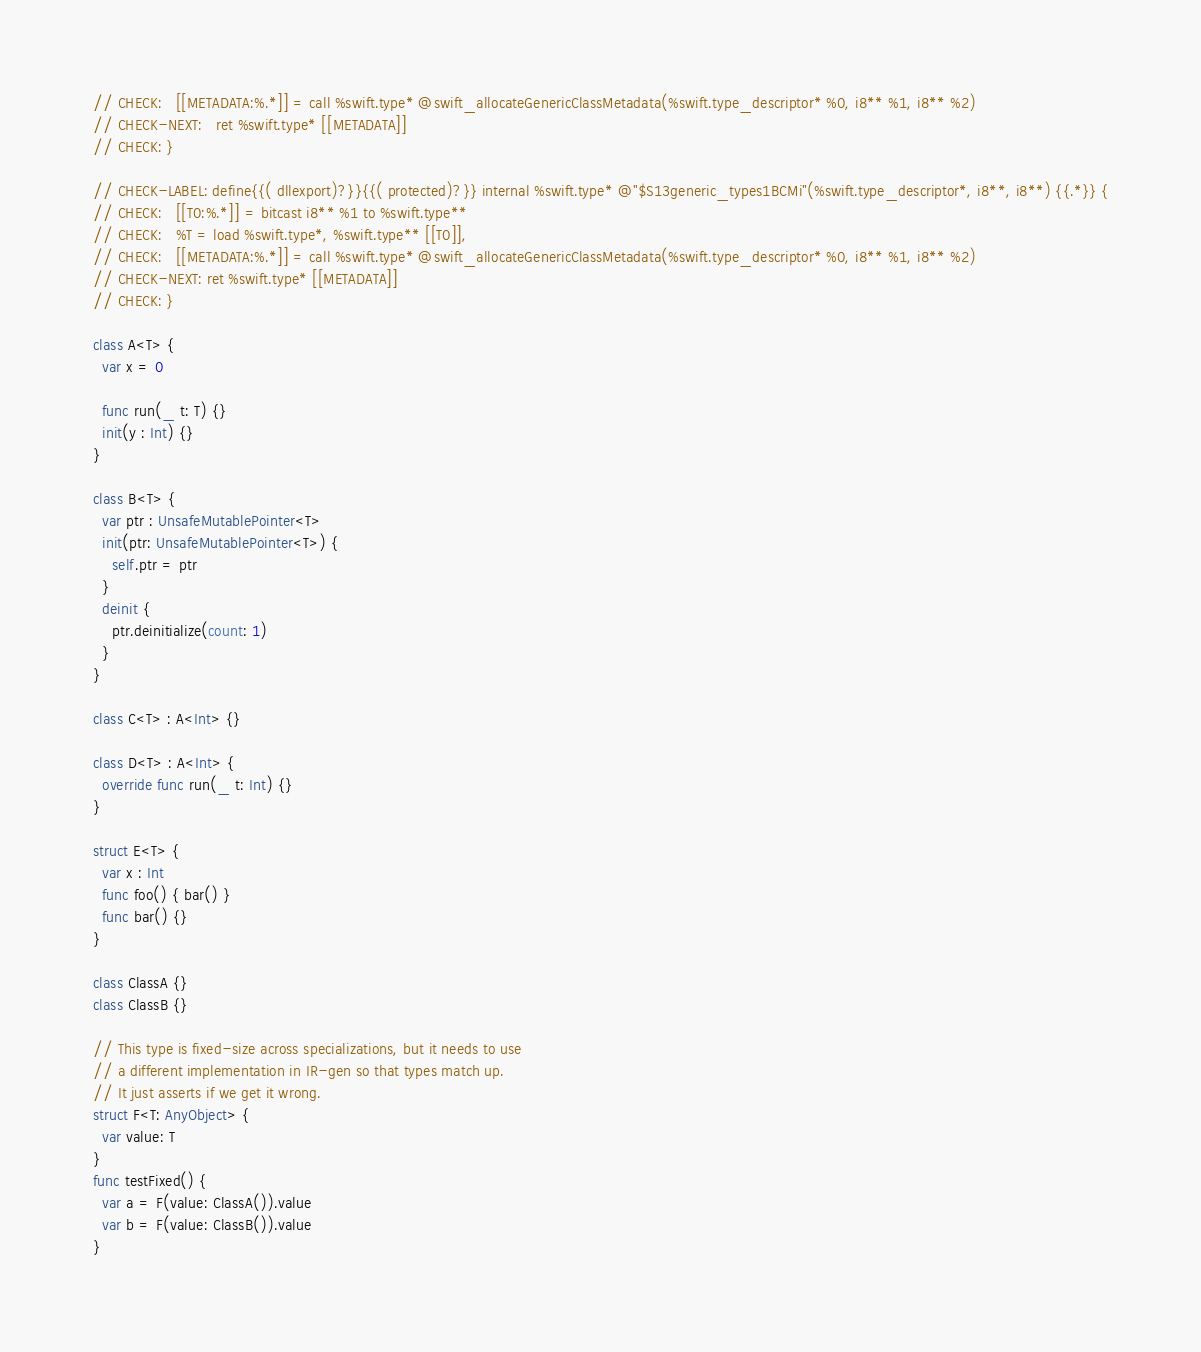Convert code to text. <code><loc_0><loc_0><loc_500><loc_500><_Swift_>// CHECK:   [[METADATA:%.*]] = call %swift.type* @swift_allocateGenericClassMetadata(%swift.type_descriptor* %0, i8** %1, i8** %2)
// CHECK-NEXT:   ret %swift.type* [[METADATA]]
// CHECK: }

// CHECK-LABEL: define{{( dllexport)?}}{{( protected)?}} internal %swift.type* @"$S13generic_types1BCMi"(%swift.type_descriptor*, i8**, i8**) {{.*}} {
// CHECK:   [[T0:%.*]] = bitcast i8** %1 to %swift.type**
// CHECK:   %T = load %swift.type*, %swift.type** [[T0]],
// CHECK:   [[METADATA:%.*]] = call %swift.type* @swift_allocateGenericClassMetadata(%swift.type_descriptor* %0, i8** %1, i8** %2)
// CHECK-NEXT: ret %swift.type* [[METADATA]]
// CHECK: }

class A<T> {
  var x = 0

  func run(_ t: T) {}
  init(y : Int) {}
}

class B<T> {
  var ptr : UnsafeMutablePointer<T>
  init(ptr: UnsafeMutablePointer<T>) {
    self.ptr = ptr
  }
  deinit {
    ptr.deinitialize(count: 1)
  }
}

class C<T> : A<Int> {}

class D<T> : A<Int> {
  override func run(_ t: Int) {}
}

struct E<T> {
  var x : Int
  func foo() { bar() }
  func bar() {}
}

class ClassA {}
class ClassB {}

// This type is fixed-size across specializations, but it needs to use
// a different implementation in IR-gen so that types match up.
// It just asserts if we get it wrong.
struct F<T: AnyObject> {
  var value: T
}
func testFixed() {
  var a = F(value: ClassA()).value
  var b = F(value: ClassB()).value
}
</code> 